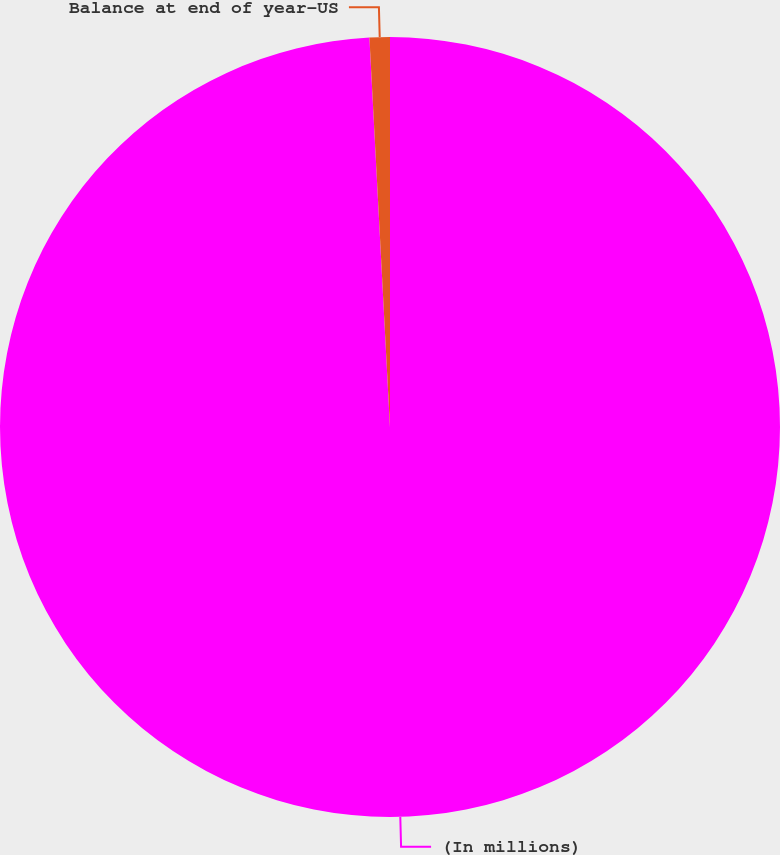Convert chart. <chart><loc_0><loc_0><loc_500><loc_500><pie_chart><fcel>(In millions)<fcel>Balance at end of year-US<nl><fcel>99.16%<fcel>0.84%<nl></chart> 